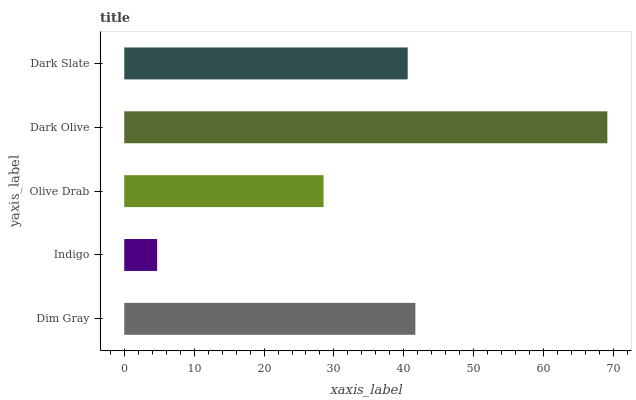Is Indigo the minimum?
Answer yes or no. Yes. Is Dark Olive the maximum?
Answer yes or no. Yes. Is Olive Drab the minimum?
Answer yes or no. No. Is Olive Drab the maximum?
Answer yes or no. No. Is Olive Drab greater than Indigo?
Answer yes or no. Yes. Is Indigo less than Olive Drab?
Answer yes or no. Yes. Is Indigo greater than Olive Drab?
Answer yes or no. No. Is Olive Drab less than Indigo?
Answer yes or no. No. Is Dark Slate the high median?
Answer yes or no. Yes. Is Dark Slate the low median?
Answer yes or no. Yes. Is Olive Drab the high median?
Answer yes or no. No. Is Olive Drab the low median?
Answer yes or no. No. 